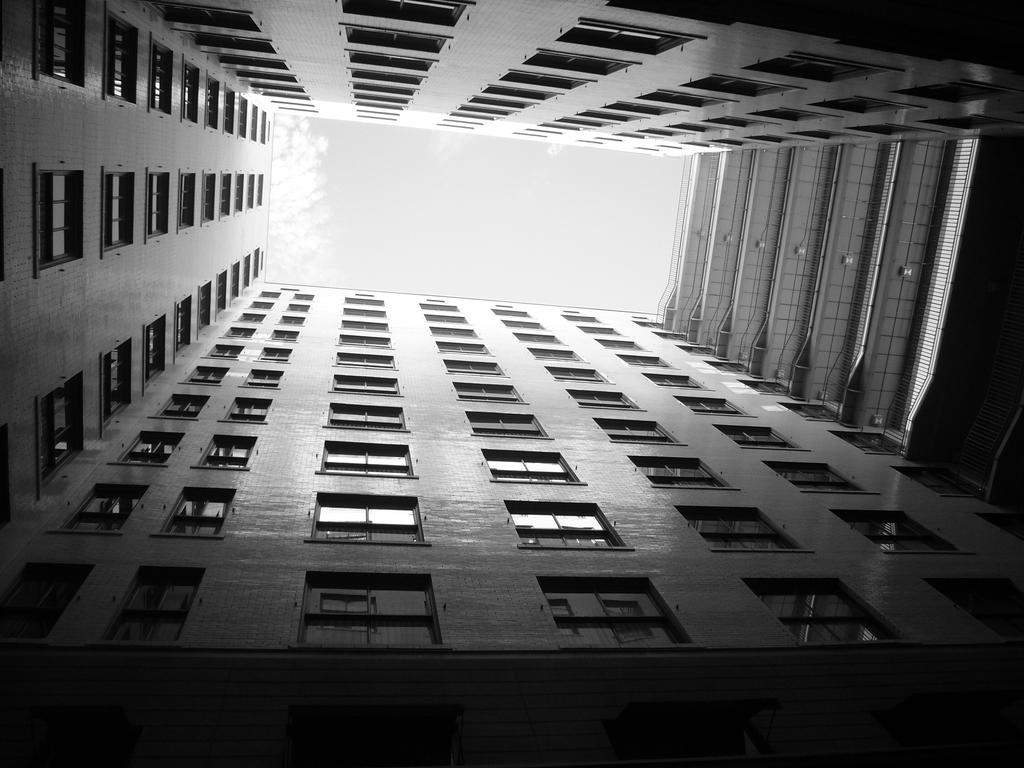What type of structure is present in the image? There is a building in the image. What part of the natural environment can be seen in the image? The sky is visible in the image. How many cherries are hanging from the tree in the image? There is no tree or cherries present in the image. Is there a gun visible in the image? There is no gun present in the image. 